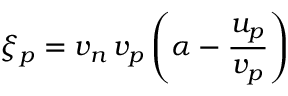<formula> <loc_0><loc_0><loc_500><loc_500>\xi _ { p } = v _ { n } \, v _ { p } \left ( \alpha - \frac { u _ { p } } { v _ { p } } \right )</formula> 